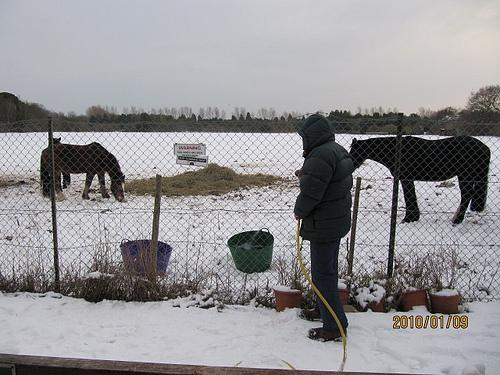What will happen to the water in the hose? Please explain your reasoning. horses drink. The man is putting out water for the horses to have. 